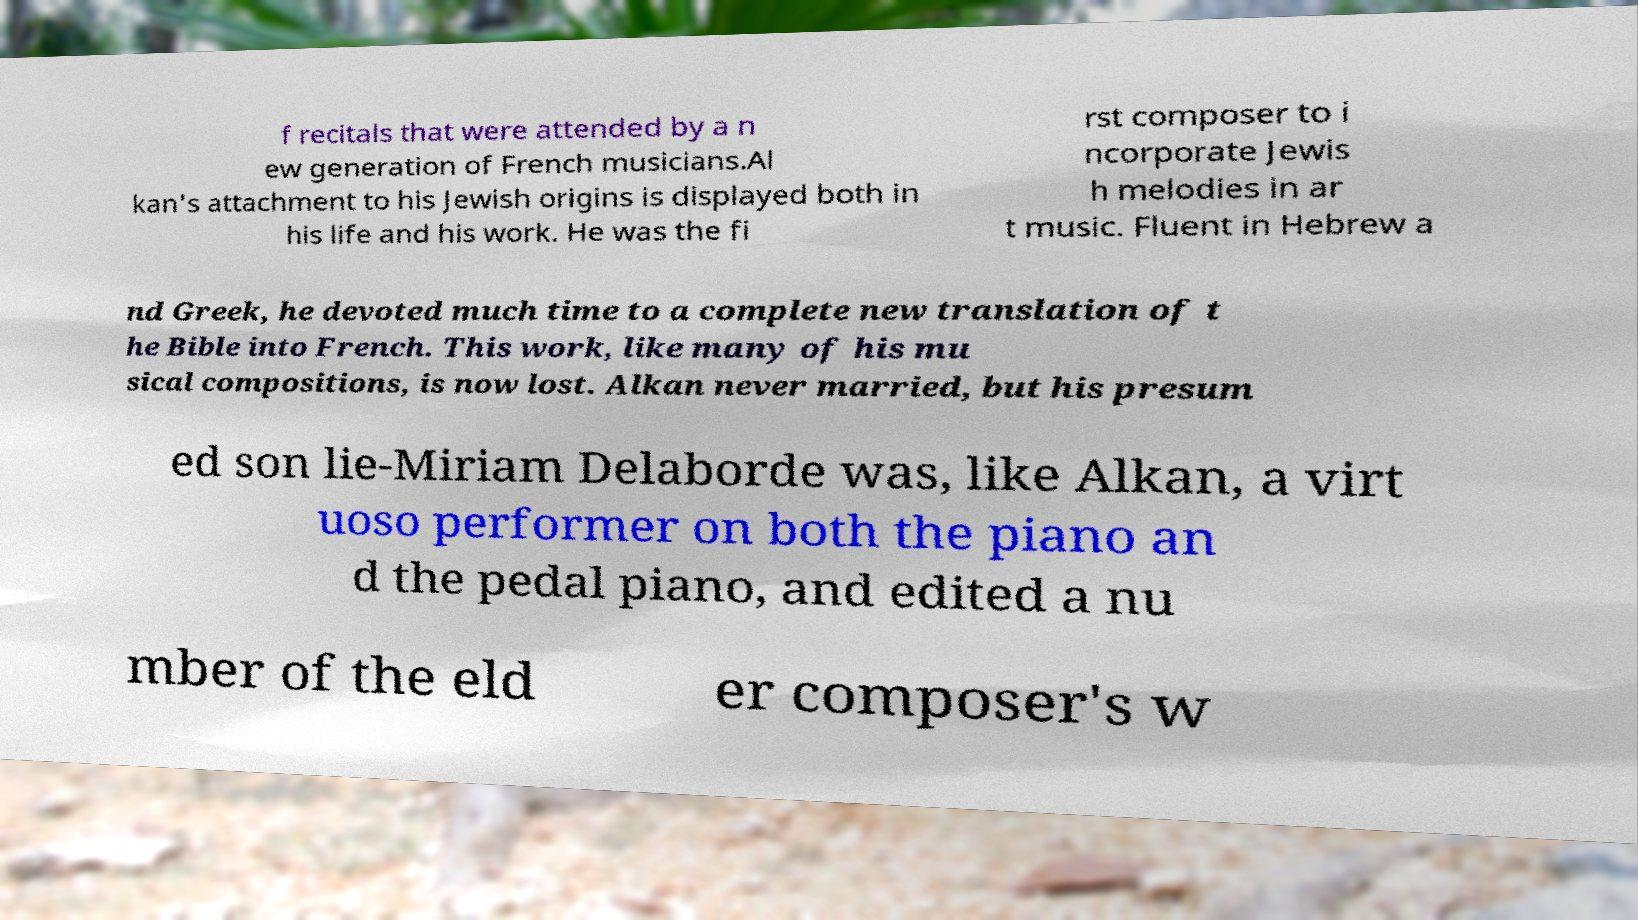For documentation purposes, I need the text within this image transcribed. Could you provide that? f recitals that were attended by a n ew generation of French musicians.Al kan's attachment to his Jewish origins is displayed both in his life and his work. He was the fi rst composer to i ncorporate Jewis h melodies in ar t music. Fluent in Hebrew a nd Greek, he devoted much time to a complete new translation of t he Bible into French. This work, like many of his mu sical compositions, is now lost. Alkan never married, but his presum ed son lie-Miriam Delaborde was, like Alkan, a virt uoso performer on both the piano an d the pedal piano, and edited a nu mber of the eld er composer's w 